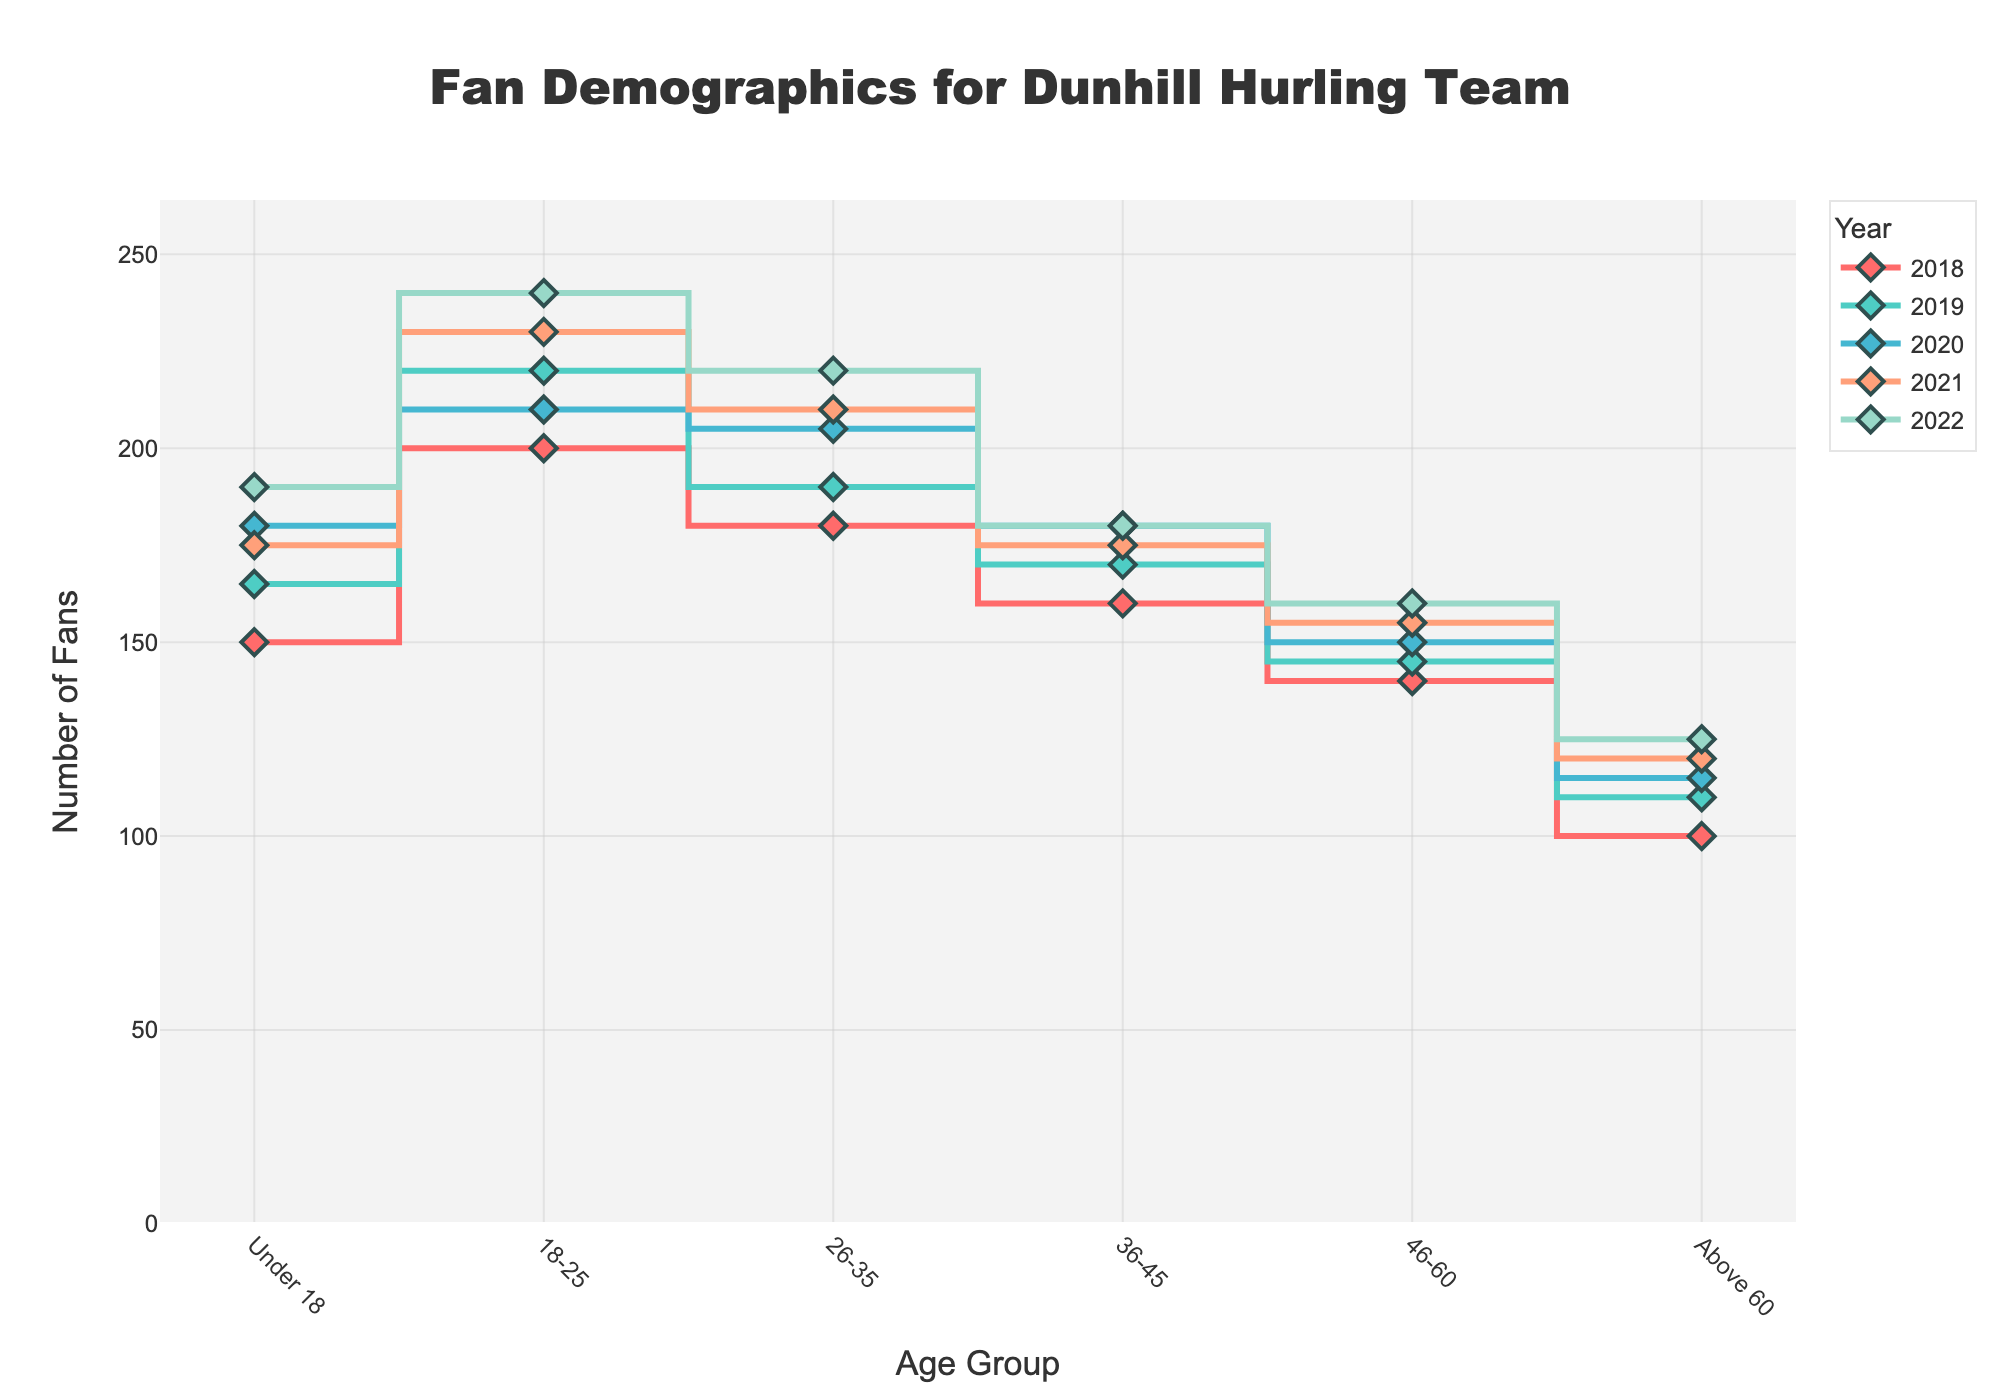Which age group had the highest number of fans in 2022? To answer this, inspect the lines for each age group for the year 2022 and identify the maximum y-axis value. The group "18-25" has the highest value at 240.
Answer: 18-25 What is the total number of fans for the 'Under 18' age group across all years? Sum the values for 'Under 18' from each year: 150 (2018) + 165 (2019) + 180 (2020) + 175 (2021) + 190 (2022). This totals to 860.
Answer: 860 By how much did the number of fans in the '18-25' age group change from 2018 to 2022? Subtract the number of fans in 2018 from the number in 2022: 240 (2022) - 200 (2018). The difference is 40.
Answer: 40 Which year had the smallest number of fans for the 'Above 60' age group? Compare the values for 'Above 60' age group for each year: 2018 (100), 2019 (110), 2020 (115), 2021 (120), 2022 (125). The smallest value is 100 in 2018.
Answer: 2018 What is the average number of fans in the '26-35' age group over all years? Sum the values for '26-35' from each year and divide by the number of years: (180 + 190 + 205 + 210 + 220) / 5. The average is 1005 / 5 = 201.
Answer: 201 Which age group showed the largest increase in fans from 2019 to 2020? Calculate the increase for each age group between these years and find the largest difference: 
- Under 18: 180 - 165 = 15
- 18-25: 210 - 220 = -10
- 26-35: 205 - 190 = 15
- 36-45: 180 - 170 = 10
- 46-60: 150 - 145 = 5
- Above 60: 115 - 110 = 5
The largest increase is for 'Under 18' and '26-35', both with an increase of 15.
Answer: Under 18 and 26-35 Did the number of fans for the '36-45' age group increase or decrease from 2020 to 2021? Compare the values for '36-45' in 2020 and 2021: 180 (2020) and 175 (2021). The value decreased from 180 to 175.
Answer: Decrease Is the number of fans in the '46-60' age group in 2021 greater than the number in 2019? Compare the values for '46-60' in 2021 (155) and 2019 (145). Since 155 is greater than 145, the answer is yes.
Answer: Yes What is the total number of fans for all age groups in 2018? Sum the number of fans for all age groups in 2018: 150 (Under 18) + 200 (18-25) + 180 (26-35) + 160 (36-45) + 140 (46-60) + 100 (Above 60). The total is 930.
Answer: 930 